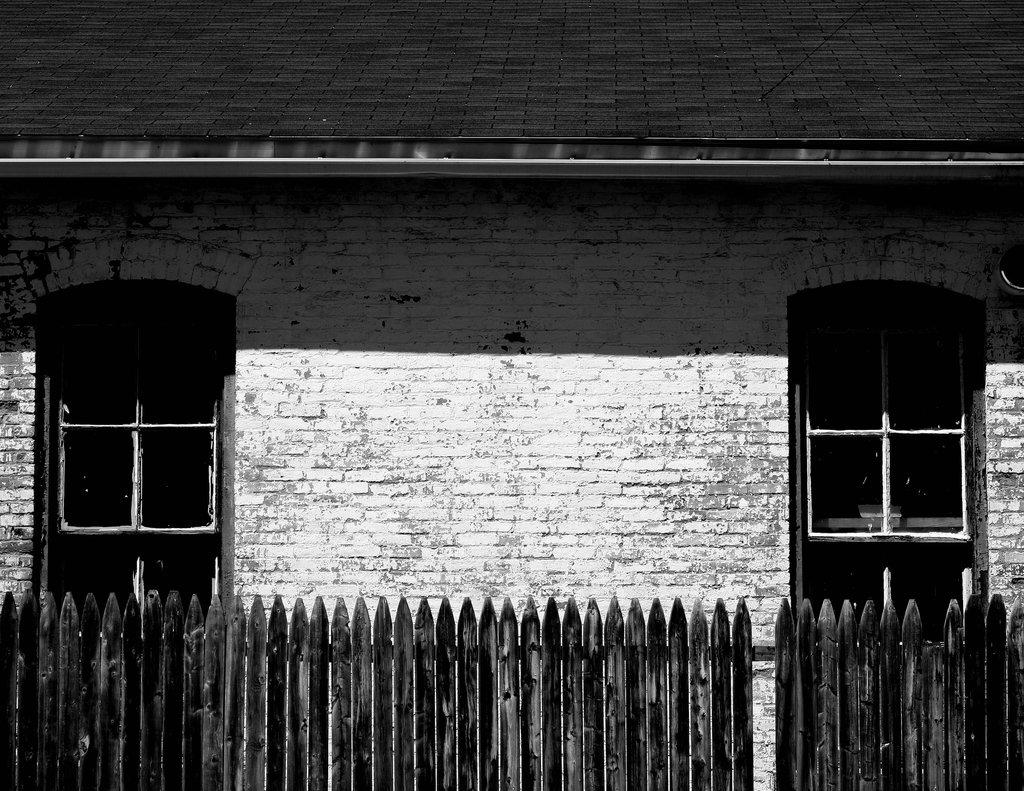What is the color scheme of the image? The image is black and white. What structure can be seen in the image? There is a building in the image. What feature of the building is visible? The building has windows. What part of the building might be depicted in the image? The image likely depicts a roof. What type of barrier is present at the bottom of the image? There is a wooden fence at the bottom of the image. What type of rice can be seen in the crate in the image? There is no rice or crate present in the image; it features a black and white building with a roof and a wooden fence. 